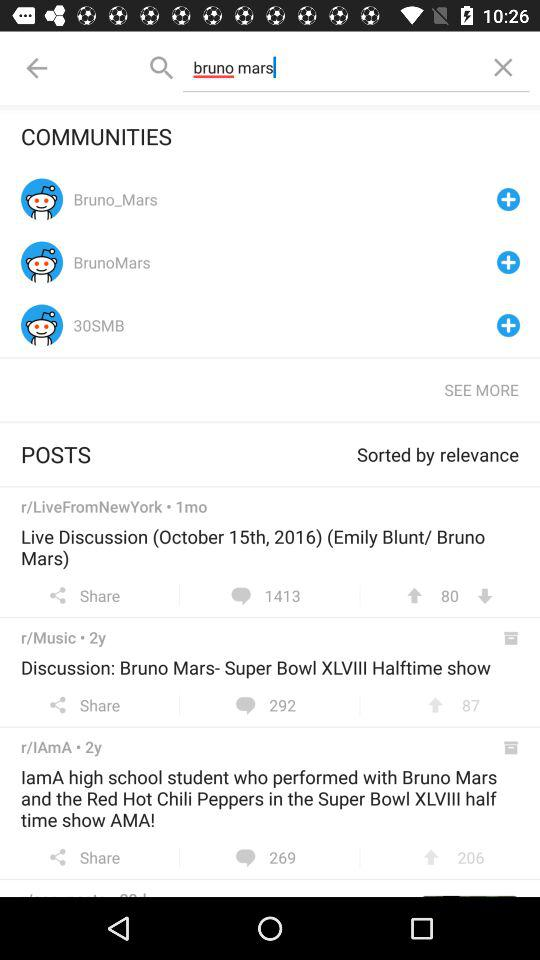How many person likes Ama?
When the provided information is insufficient, respond with <no answer>. <no answer> 